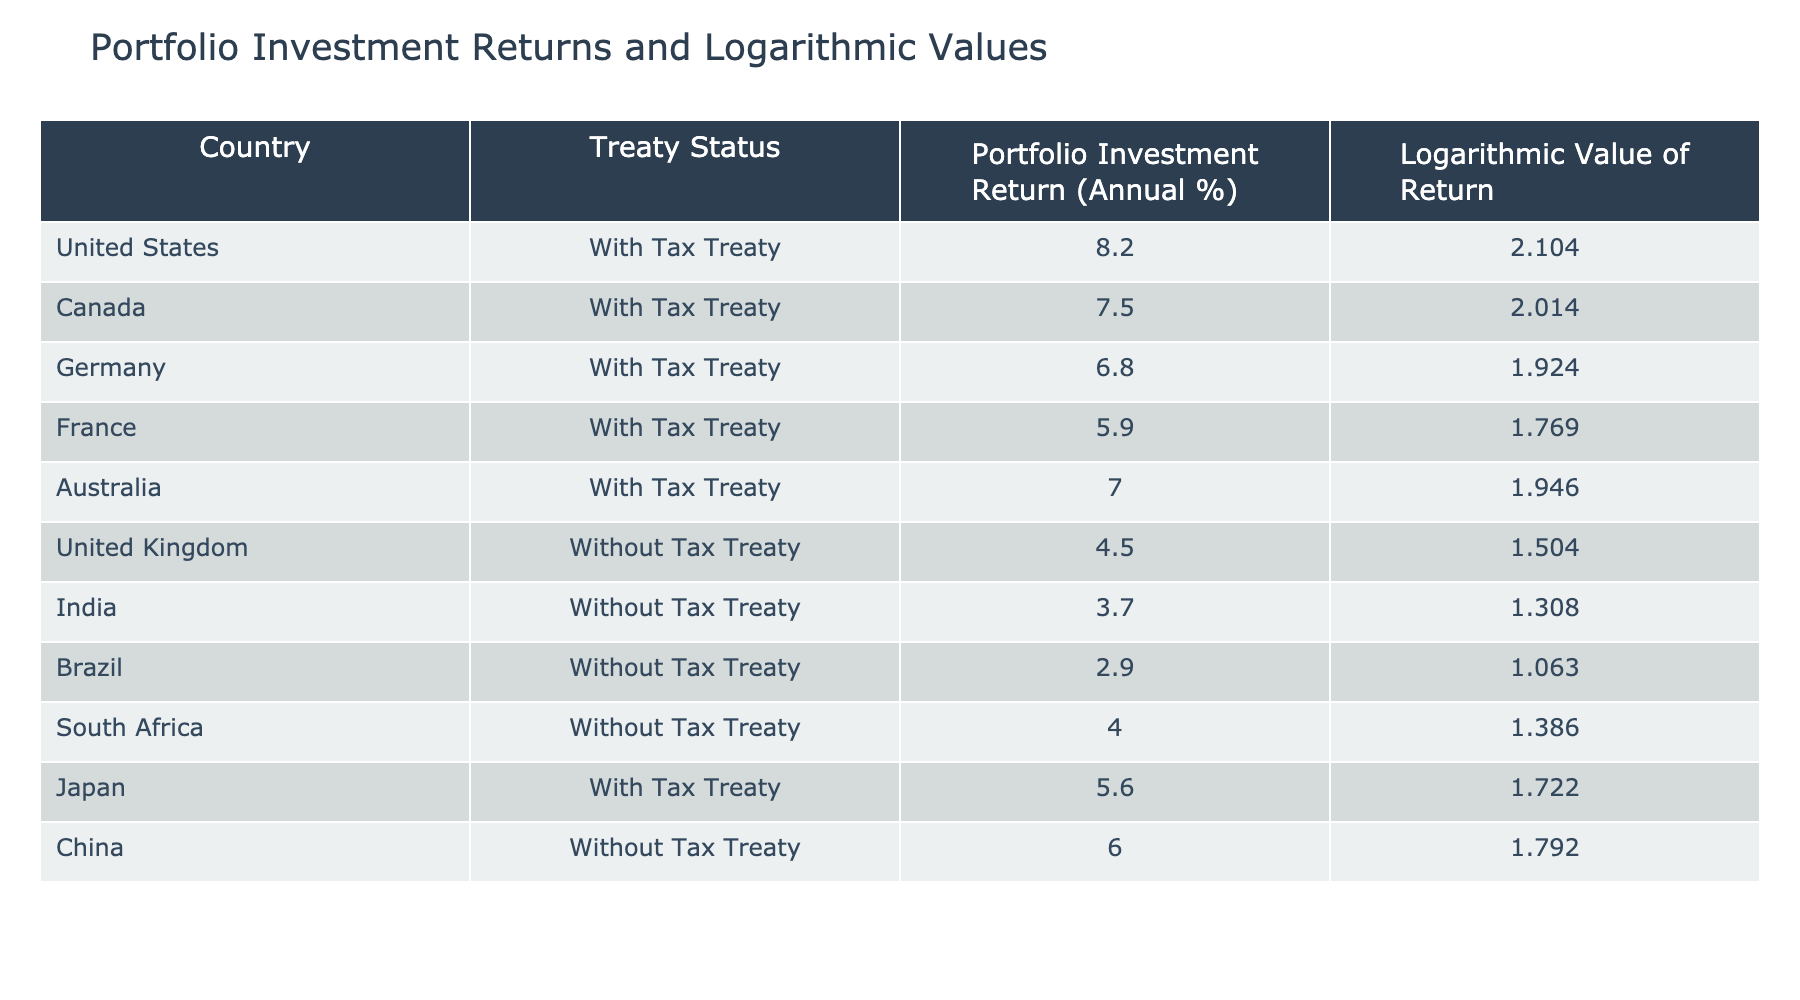What is the portfolio investment return for Japan? The table lists the portfolio investment return for Japan under the "Portfolio Investment Return (Annual %)" column, identifying it as 5.6%.
Answer: 5.6% Which country has the highest logarithmic value of return? By examining the "Logarithmic Value of Return" column, the United States has the highest value at 2.104.
Answer: United States Calculate the average portfolio investment return for countries without tax treaties. The portfolio investment returns for countries without tax treaties are 4.5 (UK), 3.7 (India), 2.9 (Brazil), 4.0 (South Africa), and 6.0 (China). The sum of these returns is 4.5 + 3.7 + 2.9 + 4.0 + 6.0 = 21.1. Then, the average is 21.1 / 5 = 4.22.
Answer: 4.22 Is the logarithmic value of return for Canada greater than that of Germany? Looking at the "Logarithmic Value of Return" column, Canada has a value of 2.014, while Germany's value is 1.924. Since 2.014 is greater than 1.924, the answer is yes.
Answer: Yes Which country with a tax treaty has a portfolio investment return lower than the return for China? The table shows that China has a portfolio investment return of 6.0%. The countries with a tax treaty and their returns are: United States (8.2), Canada (7.5), Germany (6.8), France (5.9), Australia (7.0), and Japan (5.6). Among these, only Japan at 5.6 has a return lower than 6.0.
Answer: Japan 